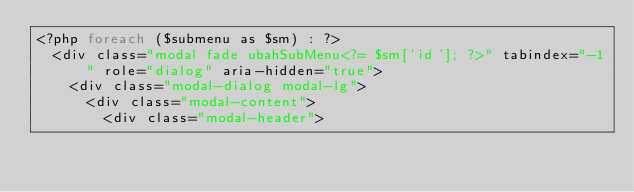<code> <loc_0><loc_0><loc_500><loc_500><_PHP_><?php foreach ($submenu as $sm) : ?>
  <div class="modal fade ubahSubMenu<?= $sm['id']; ?>" tabindex="-1" role="dialog" aria-hidden="true">
    <div class="modal-dialog modal-lg">
      <div class="modal-content">
        <div class="modal-header"></code> 